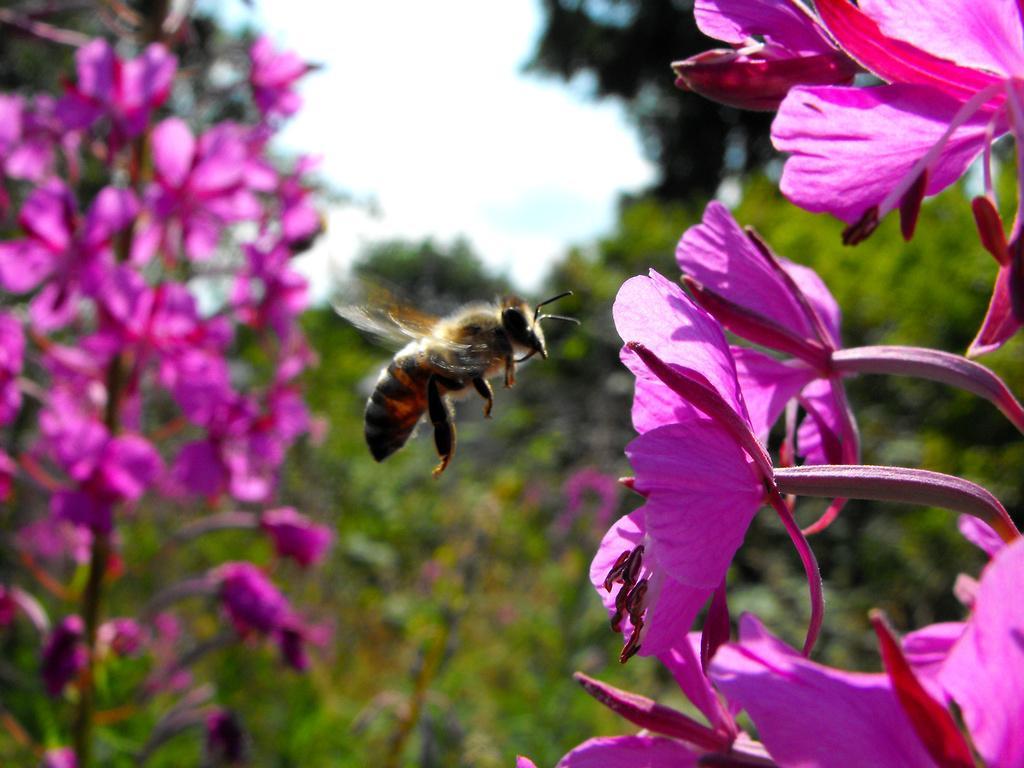How would you summarize this image in a sentence or two? In the picture we can see pink colorful flowers of the plant on either side and in the middle of it, we can see a bee flying and behind it we can see plants and above it we can see a sky. 